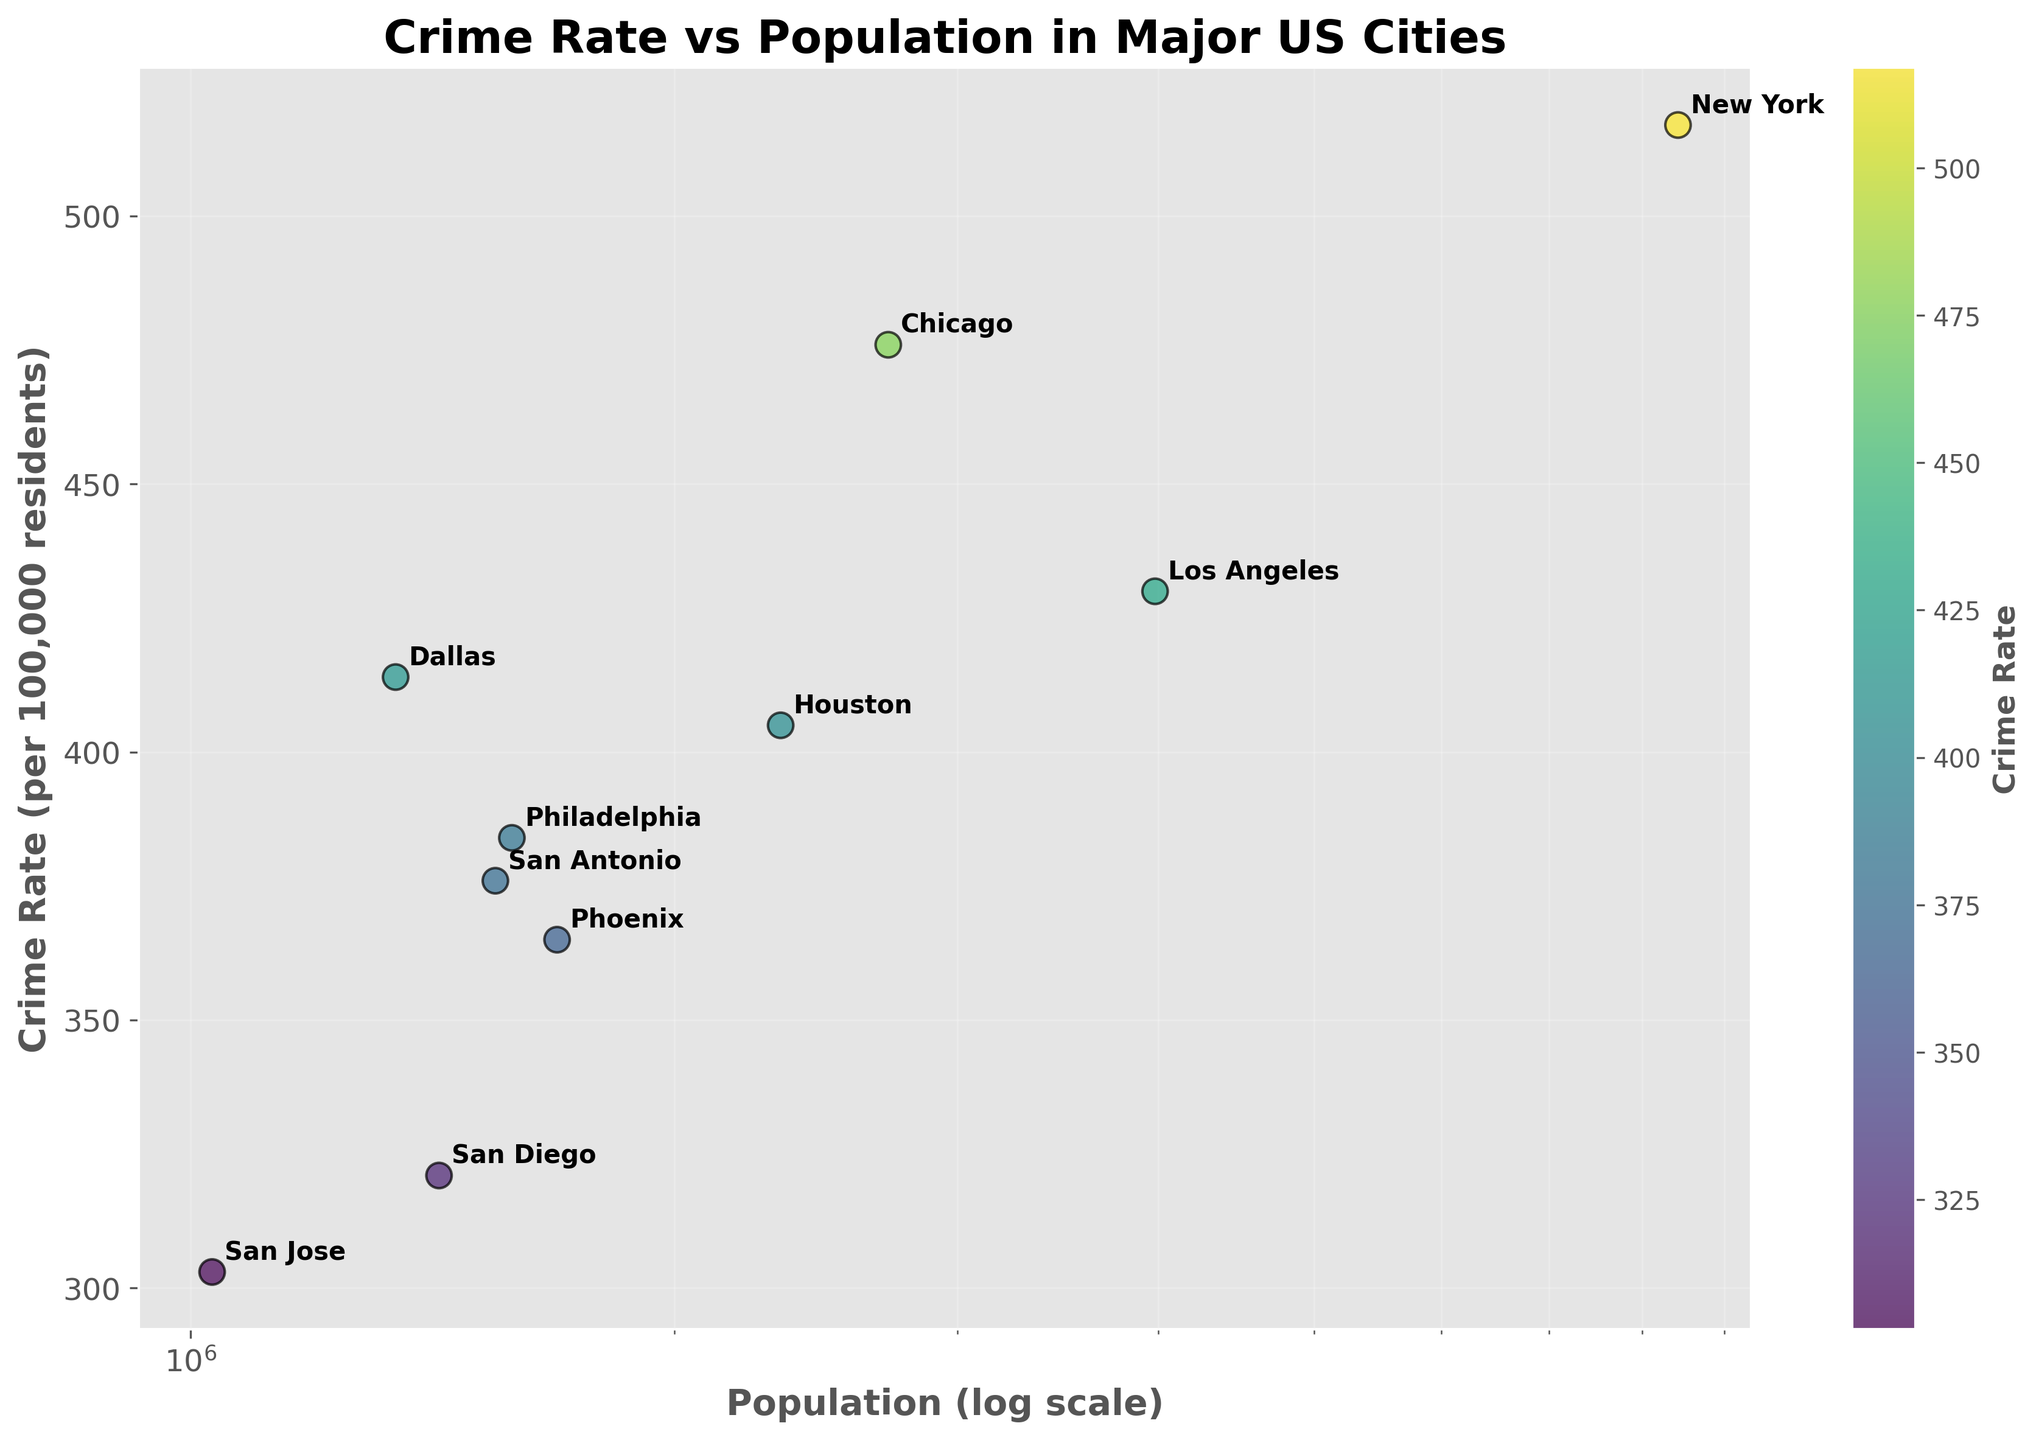What is the title of the scatter plot? The title of the scatter plot is often presented at the top center of the figure and is written in a large, bold font to capture attention.
Answer: Crime Rate vs Population in Major US Cities How many cities are represented in the scatter plot? By counting the number of data points or annotations on the scatter plot, you can determine how many cities are represented.
Answer: 10 Which city has the highest crime rate? Look for the data point with the highest value on the y-axis, which represents the crime rate. The corresponding annotation will indicate the city.
Answer: New York What is the crime rate and population of San Jose? Identify the data point labeled "San Jose" and refer to its position to determine the corresponding values on the x-axis (population) and y-axis (crime rate).
Answer: 303 (Crime Rate), 1,031,000 (Population) What is the relationship between population and crime rate for most cities? Observe the overall trend of the scatter plot. Cities with higher populations generally have a specific range of crime rates. Determine if a pattern or correlation is noticeable.
Answer: Positive correlation Which city has a higher crime rate: Chicago or Philadelphia? Compare the y-axis positions of the data points labeled "Chicago" and "Philadelphia." The city represented by the higher point has a higher crime rate.
Answer: Chicago Is there a city with a population over 2 million but a crime rate below 450? Look for data points to the right of the 2 million mark (on the x-axis) and below the 450 mark (on the y-axis). Identify the city if it exists.
Answer: Yes, Houston On what scale is the population axis set? The style and spacing of the numbers on the x-axis can reveal that a logarithmic scale is used.
Answer: Logarithmic How does the crime rate of Dallas compare to that of Los Angeles? Locate the data points for Dallas and Los Angeles, and compare their y-axis values to see which city has a higher crime rate.
Answer: Dallas is higher What can you say about San Diego's crime rate compared to most other cities? Find the data point for San Diego and compare its y-axis value to that of other cities to see if it is generally higher, lower, or about average.
Answer: San Diego has a lower crime rate 